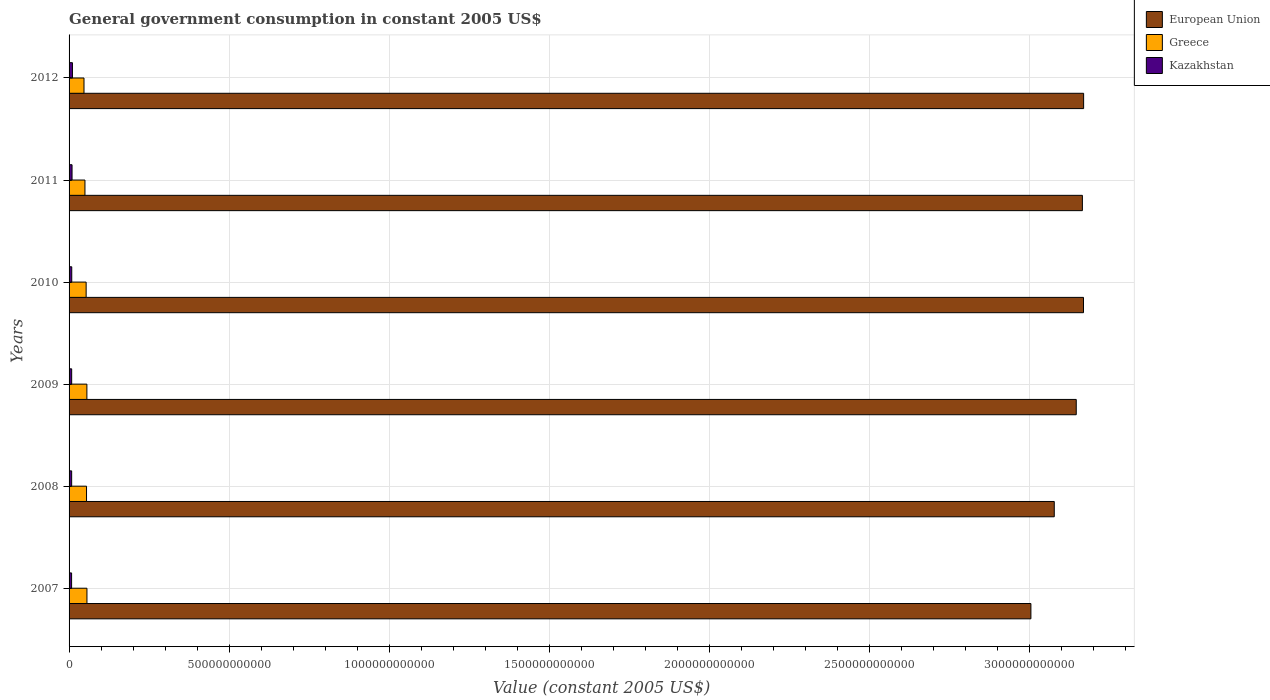How many bars are there on the 6th tick from the top?
Give a very brief answer. 3. What is the label of the 1st group of bars from the top?
Offer a terse response. 2012. What is the government conusmption in Kazakhstan in 2010?
Provide a succinct answer. 8.36e+09. Across all years, what is the maximum government conusmption in Greece?
Offer a very short reply. 5.58e+1. Across all years, what is the minimum government conusmption in European Union?
Your answer should be compact. 3.00e+12. In which year was the government conusmption in Kazakhstan maximum?
Your answer should be compact. 2012. What is the total government conusmption in Kazakhstan in the graph?
Your answer should be very brief. 5.23e+1. What is the difference between the government conusmption in European Union in 2009 and that in 2011?
Provide a short and direct response. -1.92e+1. What is the difference between the government conusmption in Greece in 2007 and the government conusmption in European Union in 2012?
Provide a succinct answer. -3.11e+12. What is the average government conusmption in Kazakhstan per year?
Make the answer very short. 8.71e+09. In the year 2009, what is the difference between the government conusmption in European Union and government conusmption in Kazakhstan?
Provide a succinct answer. 3.14e+12. What is the ratio of the government conusmption in Kazakhstan in 2007 to that in 2012?
Ensure brevity in your answer.  0.75. Is the government conusmption in Greece in 2007 less than that in 2009?
Ensure brevity in your answer.  No. What is the difference between the highest and the second highest government conusmption in Greece?
Keep it short and to the point. 1.99e+08. What is the difference between the highest and the lowest government conusmption in Greece?
Your answer should be compact. 9.24e+09. In how many years, is the government conusmption in Kazakhstan greater than the average government conusmption in Kazakhstan taken over all years?
Keep it short and to the point. 2. Is it the case that in every year, the sum of the government conusmption in European Union and government conusmption in Kazakhstan is greater than the government conusmption in Greece?
Your response must be concise. Yes. How many years are there in the graph?
Provide a succinct answer. 6. What is the difference between two consecutive major ticks on the X-axis?
Provide a short and direct response. 5.00e+11. Are the values on the major ticks of X-axis written in scientific E-notation?
Your response must be concise. No. Does the graph contain any zero values?
Your answer should be very brief. No. Does the graph contain grids?
Provide a succinct answer. Yes. Where does the legend appear in the graph?
Provide a succinct answer. Top right. What is the title of the graph?
Your response must be concise. General government consumption in constant 2005 US$. Does "Guam" appear as one of the legend labels in the graph?
Make the answer very short. No. What is the label or title of the X-axis?
Keep it short and to the point. Value (constant 2005 US$). What is the label or title of the Y-axis?
Your answer should be very brief. Years. What is the Value (constant 2005 US$) in European Union in 2007?
Provide a succinct answer. 3.00e+12. What is the Value (constant 2005 US$) in Greece in 2007?
Give a very brief answer. 5.58e+1. What is the Value (constant 2005 US$) of Kazakhstan in 2007?
Offer a very short reply. 7.86e+09. What is the Value (constant 2005 US$) of European Union in 2008?
Offer a very short reply. 3.08e+12. What is the Value (constant 2005 US$) of Greece in 2008?
Make the answer very short. 5.45e+1. What is the Value (constant 2005 US$) of Kazakhstan in 2008?
Give a very brief answer. 8.06e+09. What is the Value (constant 2005 US$) of European Union in 2009?
Provide a succinct answer. 3.15e+12. What is the Value (constant 2005 US$) in Greece in 2009?
Your answer should be compact. 5.56e+1. What is the Value (constant 2005 US$) of Kazakhstan in 2009?
Your answer should be compact. 8.14e+09. What is the Value (constant 2005 US$) in European Union in 2010?
Give a very brief answer. 3.17e+12. What is the Value (constant 2005 US$) of Greece in 2010?
Your response must be concise. 5.33e+1. What is the Value (constant 2005 US$) of Kazakhstan in 2010?
Your answer should be very brief. 8.36e+09. What is the Value (constant 2005 US$) of European Union in 2011?
Offer a terse response. 3.16e+12. What is the Value (constant 2005 US$) of Greece in 2011?
Keep it short and to the point. 4.96e+1. What is the Value (constant 2005 US$) of Kazakhstan in 2011?
Give a very brief answer. 9.31e+09. What is the Value (constant 2005 US$) in European Union in 2012?
Give a very brief answer. 3.17e+12. What is the Value (constant 2005 US$) in Greece in 2012?
Ensure brevity in your answer.  4.66e+1. What is the Value (constant 2005 US$) of Kazakhstan in 2012?
Offer a very short reply. 1.05e+1. Across all years, what is the maximum Value (constant 2005 US$) of European Union?
Give a very brief answer. 3.17e+12. Across all years, what is the maximum Value (constant 2005 US$) of Greece?
Keep it short and to the point. 5.58e+1. Across all years, what is the maximum Value (constant 2005 US$) in Kazakhstan?
Provide a succinct answer. 1.05e+1. Across all years, what is the minimum Value (constant 2005 US$) of European Union?
Offer a very short reply. 3.00e+12. Across all years, what is the minimum Value (constant 2005 US$) of Greece?
Offer a terse response. 4.66e+1. Across all years, what is the minimum Value (constant 2005 US$) of Kazakhstan?
Provide a short and direct response. 7.86e+09. What is the total Value (constant 2005 US$) in European Union in the graph?
Give a very brief answer. 1.87e+13. What is the total Value (constant 2005 US$) of Greece in the graph?
Keep it short and to the point. 3.16e+11. What is the total Value (constant 2005 US$) of Kazakhstan in the graph?
Your answer should be compact. 5.23e+1. What is the difference between the Value (constant 2005 US$) in European Union in 2007 and that in 2008?
Provide a succinct answer. -7.30e+1. What is the difference between the Value (constant 2005 US$) of Greece in 2007 and that in 2008?
Keep it short and to the point. 1.30e+09. What is the difference between the Value (constant 2005 US$) in Kazakhstan in 2007 and that in 2008?
Make the answer very short. -2.04e+08. What is the difference between the Value (constant 2005 US$) in European Union in 2007 and that in 2009?
Ensure brevity in your answer.  -1.42e+11. What is the difference between the Value (constant 2005 US$) of Greece in 2007 and that in 2009?
Your answer should be very brief. 1.99e+08. What is the difference between the Value (constant 2005 US$) in Kazakhstan in 2007 and that in 2009?
Ensure brevity in your answer.  -2.85e+08. What is the difference between the Value (constant 2005 US$) of European Union in 2007 and that in 2010?
Offer a terse response. -1.64e+11. What is the difference between the Value (constant 2005 US$) of Greece in 2007 and that in 2010?
Your response must be concise. 2.52e+09. What is the difference between the Value (constant 2005 US$) in Kazakhstan in 2007 and that in 2010?
Your answer should be very brief. -5.05e+08. What is the difference between the Value (constant 2005 US$) in European Union in 2007 and that in 2011?
Keep it short and to the point. -1.61e+11. What is the difference between the Value (constant 2005 US$) of Greece in 2007 and that in 2011?
Keep it short and to the point. 6.26e+09. What is the difference between the Value (constant 2005 US$) in Kazakhstan in 2007 and that in 2011?
Your answer should be compact. -1.45e+09. What is the difference between the Value (constant 2005 US$) of European Union in 2007 and that in 2012?
Offer a terse response. -1.65e+11. What is the difference between the Value (constant 2005 US$) of Greece in 2007 and that in 2012?
Keep it short and to the point. 9.24e+09. What is the difference between the Value (constant 2005 US$) in Kazakhstan in 2007 and that in 2012?
Your response must be concise. -2.68e+09. What is the difference between the Value (constant 2005 US$) in European Union in 2008 and that in 2009?
Your answer should be very brief. -6.86e+1. What is the difference between the Value (constant 2005 US$) in Greece in 2008 and that in 2009?
Offer a terse response. -1.10e+09. What is the difference between the Value (constant 2005 US$) of Kazakhstan in 2008 and that in 2009?
Offer a very short reply. -8.06e+07. What is the difference between the Value (constant 2005 US$) of European Union in 2008 and that in 2010?
Your response must be concise. -9.13e+1. What is the difference between the Value (constant 2005 US$) in Greece in 2008 and that in 2010?
Ensure brevity in your answer.  1.22e+09. What is the difference between the Value (constant 2005 US$) of Kazakhstan in 2008 and that in 2010?
Ensure brevity in your answer.  -3.01e+08. What is the difference between the Value (constant 2005 US$) in European Union in 2008 and that in 2011?
Ensure brevity in your answer.  -8.78e+1. What is the difference between the Value (constant 2005 US$) in Greece in 2008 and that in 2011?
Provide a succinct answer. 4.96e+09. What is the difference between the Value (constant 2005 US$) of Kazakhstan in 2008 and that in 2011?
Provide a short and direct response. -1.25e+09. What is the difference between the Value (constant 2005 US$) in European Union in 2008 and that in 2012?
Provide a short and direct response. -9.17e+1. What is the difference between the Value (constant 2005 US$) of Greece in 2008 and that in 2012?
Your response must be concise. 7.93e+09. What is the difference between the Value (constant 2005 US$) of Kazakhstan in 2008 and that in 2012?
Your answer should be very brief. -2.47e+09. What is the difference between the Value (constant 2005 US$) of European Union in 2009 and that in 2010?
Make the answer very short. -2.27e+1. What is the difference between the Value (constant 2005 US$) of Greece in 2009 and that in 2010?
Your answer should be very brief. 2.32e+09. What is the difference between the Value (constant 2005 US$) of Kazakhstan in 2009 and that in 2010?
Your answer should be very brief. -2.20e+08. What is the difference between the Value (constant 2005 US$) of European Union in 2009 and that in 2011?
Give a very brief answer. -1.92e+1. What is the difference between the Value (constant 2005 US$) of Greece in 2009 and that in 2011?
Offer a very short reply. 6.06e+09. What is the difference between the Value (constant 2005 US$) in Kazakhstan in 2009 and that in 2011?
Offer a very short reply. -1.17e+09. What is the difference between the Value (constant 2005 US$) of European Union in 2009 and that in 2012?
Your answer should be very brief. -2.31e+1. What is the difference between the Value (constant 2005 US$) of Greece in 2009 and that in 2012?
Your answer should be very brief. 9.04e+09. What is the difference between the Value (constant 2005 US$) in Kazakhstan in 2009 and that in 2012?
Your answer should be compact. -2.39e+09. What is the difference between the Value (constant 2005 US$) of European Union in 2010 and that in 2011?
Make the answer very short. 3.47e+09. What is the difference between the Value (constant 2005 US$) of Greece in 2010 and that in 2011?
Make the answer very short. 3.74e+09. What is the difference between the Value (constant 2005 US$) of Kazakhstan in 2010 and that in 2011?
Your answer should be compact. -9.45e+08. What is the difference between the Value (constant 2005 US$) in European Union in 2010 and that in 2012?
Your answer should be compact. -3.98e+08. What is the difference between the Value (constant 2005 US$) in Greece in 2010 and that in 2012?
Your answer should be compact. 6.72e+09. What is the difference between the Value (constant 2005 US$) in Kazakhstan in 2010 and that in 2012?
Your response must be concise. -2.17e+09. What is the difference between the Value (constant 2005 US$) in European Union in 2011 and that in 2012?
Offer a terse response. -3.87e+09. What is the difference between the Value (constant 2005 US$) of Greece in 2011 and that in 2012?
Provide a short and direct response. 2.97e+09. What is the difference between the Value (constant 2005 US$) of Kazakhstan in 2011 and that in 2012?
Provide a succinct answer. -1.23e+09. What is the difference between the Value (constant 2005 US$) of European Union in 2007 and the Value (constant 2005 US$) of Greece in 2008?
Keep it short and to the point. 2.95e+12. What is the difference between the Value (constant 2005 US$) in European Union in 2007 and the Value (constant 2005 US$) in Kazakhstan in 2008?
Give a very brief answer. 3.00e+12. What is the difference between the Value (constant 2005 US$) of Greece in 2007 and the Value (constant 2005 US$) of Kazakhstan in 2008?
Provide a short and direct response. 4.78e+1. What is the difference between the Value (constant 2005 US$) of European Union in 2007 and the Value (constant 2005 US$) of Greece in 2009?
Your answer should be very brief. 2.95e+12. What is the difference between the Value (constant 2005 US$) in European Union in 2007 and the Value (constant 2005 US$) in Kazakhstan in 2009?
Your answer should be very brief. 3.00e+12. What is the difference between the Value (constant 2005 US$) in Greece in 2007 and the Value (constant 2005 US$) in Kazakhstan in 2009?
Your response must be concise. 4.77e+1. What is the difference between the Value (constant 2005 US$) of European Union in 2007 and the Value (constant 2005 US$) of Greece in 2010?
Provide a short and direct response. 2.95e+12. What is the difference between the Value (constant 2005 US$) of European Union in 2007 and the Value (constant 2005 US$) of Kazakhstan in 2010?
Provide a succinct answer. 3.00e+12. What is the difference between the Value (constant 2005 US$) in Greece in 2007 and the Value (constant 2005 US$) in Kazakhstan in 2010?
Give a very brief answer. 4.75e+1. What is the difference between the Value (constant 2005 US$) of European Union in 2007 and the Value (constant 2005 US$) of Greece in 2011?
Provide a succinct answer. 2.95e+12. What is the difference between the Value (constant 2005 US$) in European Union in 2007 and the Value (constant 2005 US$) in Kazakhstan in 2011?
Your response must be concise. 2.99e+12. What is the difference between the Value (constant 2005 US$) of Greece in 2007 and the Value (constant 2005 US$) of Kazakhstan in 2011?
Ensure brevity in your answer.  4.65e+1. What is the difference between the Value (constant 2005 US$) in European Union in 2007 and the Value (constant 2005 US$) in Greece in 2012?
Ensure brevity in your answer.  2.96e+12. What is the difference between the Value (constant 2005 US$) of European Union in 2007 and the Value (constant 2005 US$) of Kazakhstan in 2012?
Offer a very short reply. 2.99e+12. What is the difference between the Value (constant 2005 US$) in Greece in 2007 and the Value (constant 2005 US$) in Kazakhstan in 2012?
Your response must be concise. 4.53e+1. What is the difference between the Value (constant 2005 US$) of European Union in 2008 and the Value (constant 2005 US$) of Greece in 2009?
Make the answer very short. 3.02e+12. What is the difference between the Value (constant 2005 US$) of European Union in 2008 and the Value (constant 2005 US$) of Kazakhstan in 2009?
Give a very brief answer. 3.07e+12. What is the difference between the Value (constant 2005 US$) in Greece in 2008 and the Value (constant 2005 US$) in Kazakhstan in 2009?
Give a very brief answer. 4.64e+1. What is the difference between the Value (constant 2005 US$) in European Union in 2008 and the Value (constant 2005 US$) in Greece in 2010?
Your answer should be compact. 3.02e+12. What is the difference between the Value (constant 2005 US$) of European Union in 2008 and the Value (constant 2005 US$) of Kazakhstan in 2010?
Provide a short and direct response. 3.07e+12. What is the difference between the Value (constant 2005 US$) of Greece in 2008 and the Value (constant 2005 US$) of Kazakhstan in 2010?
Your answer should be compact. 4.62e+1. What is the difference between the Value (constant 2005 US$) in European Union in 2008 and the Value (constant 2005 US$) in Greece in 2011?
Your answer should be very brief. 3.03e+12. What is the difference between the Value (constant 2005 US$) of European Union in 2008 and the Value (constant 2005 US$) of Kazakhstan in 2011?
Provide a succinct answer. 3.07e+12. What is the difference between the Value (constant 2005 US$) of Greece in 2008 and the Value (constant 2005 US$) of Kazakhstan in 2011?
Your response must be concise. 4.52e+1. What is the difference between the Value (constant 2005 US$) of European Union in 2008 and the Value (constant 2005 US$) of Greece in 2012?
Your answer should be very brief. 3.03e+12. What is the difference between the Value (constant 2005 US$) in European Union in 2008 and the Value (constant 2005 US$) in Kazakhstan in 2012?
Make the answer very short. 3.07e+12. What is the difference between the Value (constant 2005 US$) of Greece in 2008 and the Value (constant 2005 US$) of Kazakhstan in 2012?
Offer a very short reply. 4.40e+1. What is the difference between the Value (constant 2005 US$) in European Union in 2009 and the Value (constant 2005 US$) in Greece in 2010?
Provide a succinct answer. 3.09e+12. What is the difference between the Value (constant 2005 US$) of European Union in 2009 and the Value (constant 2005 US$) of Kazakhstan in 2010?
Ensure brevity in your answer.  3.14e+12. What is the difference between the Value (constant 2005 US$) of Greece in 2009 and the Value (constant 2005 US$) of Kazakhstan in 2010?
Your answer should be very brief. 4.73e+1. What is the difference between the Value (constant 2005 US$) of European Union in 2009 and the Value (constant 2005 US$) of Greece in 2011?
Ensure brevity in your answer.  3.10e+12. What is the difference between the Value (constant 2005 US$) in European Union in 2009 and the Value (constant 2005 US$) in Kazakhstan in 2011?
Your response must be concise. 3.14e+12. What is the difference between the Value (constant 2005 US$) in Greece in 2009 and the Value (constant 2005 US$) in Kazakhstan in 2011?
Provide a succinct answer. 4.63e+1. What is the difference between the Value (constant 2005 US$) of European Union in 2009 and the Value (constant 2005 US$) of Greece in 2012?
Your answer should be very brief. 3.10e+12. What is the difference between the Value (constant 2005 US$) in European Union in 2009 and the Value (constant 2005 US$) in Kazakhstan in 2012?
Ensure brevity in your answer.  3.13e+12. What is the difference between the Value (constant 2005 US$) in Greece in 2009 and the Value (constant 2005 US$) in Kazakhstan in 2012?
Provide a succinct answer. 4.51e+1. What is the difference between the Value (constant 2005 US$) of European Union in 2010 and the Value (constant 2005 US$) of Greece in 2011?
Ensure brevity in your answer.  3.12e+12. What is the difference between the Value (constant 2005 US$) in European Union in 2010 and the Value (constant 2005 US$) in Kazakhstan in 2011?
Give a very brief answer. 3.16e+12. What is the difference between the Value (constant 2005 US$) in Greece in 2010 and the Value (constant 2005 US$) in Kazakhstan in 2011?
Keep it short and to the point. 4.40e+1. What is the difference between the Value (constant 2005 US$) of European Union in 2010 and the Value (constant 2005 US$) of Greece in 2012?
Offer a terse response. 3.12e+12. What is the difference between the Value (constant 2005 US$) in European Union in 2010 and the Value (constant 2005 US$) in Kazakhstan in 2012?
Offer a very short reply. 3.16e+12. What is the difference between the Value (constant 2005 US$) of Greece in 2010 and the Value (constant 2005 US$) of Kazakhstan in 2012?
Your answer should be very brief. 4.28e+1. What is the difference between the Value (constant 2005 US$) of European Union in 2011 and the Value (constant 2005 US$) of Greece in 2012?
Provide a succinct answer. 3.12e+12. What is the difference between the Value (constant 2005 US$) of European Union in 2011 and the Value (constant 2005 US$) of Kazakhstan in 2012?
Provide a succinct answer. 3.15e+12. What is the difference between the Value (constant 2005 US$) of Greece in 2011 and the Value (constant 2005 US$) of Kazakhstan in 2012?
Your answer should be compact. 3.90e+1. What is the average Value (constant 2005 US$) of European Union per year?
Keep it short and to the point. 3.12e+12. What is the average Value (constant 2005 US$) in Greece per year?
Offer a terse response. 5.26e+1. What is the average Value (constant 2005 US$) of Kazakhstan per year?
Ensure brevity in your answer.  8.71e+09. In the year 2007, what is the difference between the Value (constant 2005 US$) of European Union and Value (constant 2005 US$) of Greece?
Give a very brief answer. 2.95e+12. In the year 2007, what is the difference between the Value (constant 2005 US$) in European Union and Value (constant 2005 US$) in Kazakhstan?
Provide a short and direct response. 3.00e+12. In the year 2007, what is the difference between the Value (constant 2005 US$) in Greece and Value (constant 2005 US$) in Kazakhstan?
Your answer should be compact. 4.80e+1. In the year 2008, what is the difference between the Value (constant 2005 US$) in European Union and Value (constant 2005 US$) in Greece?
Offer a very short reply. 3.02e+12. In the year 2008, what is the difference between the Value (constant 2005 US$) of European Union and Value (constant 2005 US$) of Kazakhstan?
Provide a succinct answer. 3.07e+12. In the year 2008, what is the difference between the Value (constant 2005 US$) in Greece and Value (constant 2005 US$) in Kazakhstan?
Keep it short and to the point. 4.65e+1. In the year 2009, what is the difference between the Value (constant 2005 US$) of European Union and Value (constant 2005 US$) of Greece?
Provide a succinct answer. 3.09e+12. In the year 2009, what is the difference between the Value (constant 2005 US$) in European Union and Value (constant 2005 US$) in Kazakhstan?
Ensure brevity in your answer.  3.14e+12. In the year 2009, what is the difference between the Value (constant 2005 US$) in Greece and Value (constant 2005 US$) in Kazakhstan?
Your answer should be compact. 4.75e+1. In the year 2010, what is the difference between the Value (constant 2005 US$) of European Union and Value (constant 2005 US$) of Greece?
Give a very brief answer. 3.11e+12. In the year 2010, what is the difference between the Value (constant 2005 US$) in European Union and Value (constant 2005 US$) in Kazakhstan?
Provide a short and direct response. 3.16e+12. In the year 2010, what is the difference between the Value (constant 2005 US$) of Greece and Value (constant 2005 US$) of Kazakhstan?
Make the answer very short. 4.50e+1. In the year 2011, what is the difference between the Value (constant 2005 US$) in European Union and Value (constant 2005 US$) in Greece?
Ensure brevity in your answer.  3.11e+12. In the year 2011, what is the difference between the Value (constant 2005 US$) of European Union and Value (constant 2005 US$) of Kazakhstan?
Your answer should be very brief. 3.16e+12. In the year 2011, what is the difference between the Value (constant 2005 US$) of Greece and Value (constant 2005 US$) of Kazakhstan?
Provide a succinct answer. 4.03e+1. In the year 2012, what is the difference between the Value (constant 2005 US$) of European Union and Value (constant 2005 US$) of Greece?
Your response must be concise. 3.12e+12. In the year 2012, what is the difference between the Value (constant 2005 US$) in European Union and Value (constant 2005 US$) in Kazakhstan?
Ensure brevity in your answer.  3.16e+12. In the year 2012, what is the difference between the Value (constant 2005 US$) of Greece and Value (constant 2005 US$) of Kazakhstan?
Your response must be concise. 3.61e+1. What is the ratio of the Value (constant 2005 US$) in European Union in 2007 to that in 2008?
Your answer should be compact. 0.98. What is the ratio of the Value (constant 2005 US$) in Greece in 2007 to that in 2008?
Provide a succinct answer. 1.02. What is the ratio of the Value (constant 2005 US$) in Kazakhstan in 2007 to that in 2008?
Give a very brief answer. 0.97. What is the ratio of the Value (constant 2005 US$) in European Union in 2007 to that in 2009?
Your answer should be compact. 0.95. What is the ratio of the Value (constant 2005 US$) in Greece in 2007 to that in 2009?
Offer a terse response. 1. What is the ratio of the Value (constant 2005 US$) in Kazakhstan in 2007 to that in 2009?
Offer a terse response. 0.96. What is the ratio of the Value (constant 2005 US$) of European Union in 2007 to that in 2010?
Provide a succinct answer. 0.95. What is the ratio of the Value (constant 2005 US$) in Greece in 2007 to that in 2010?
Provide a short and direct response. 1.05. What is the ratio of the Value (constant 2005 US$) in Kazakhstan in 2007 to that in 2010?
Provide a succinct answer. 0.94. What is the ratio of the Value (constant 2005 US$) in European Union in 2007 to that in 2011?
Provide a succinct answer. 0.95. What is the ratio of the Value (constant 2005 US$) of Greece in 2007 to that in 2011?
Provide a succinct answer. 1.13. What is the ratio of the Value (constant 2005 US$) in Kazakhstan in 2007 to that in 2011?
Your answer should be compact. 0.84. What is the ratio of the Value (constant 2005 US$) in European Union in 2007 to that in 2012?
Your answer should be very brief. 0.95. What is the ratio of the Value (constant 2005 US$) in Greece in 2007 to that in 2012?
Make the answer very short. 1.2. What is the ratio of the Value (constant 2005 US$) of Kazakhstan in 2007 to that in 2012?
Provide a succinct answer. 0.75. What is the ratio of the Value (constant 2005 US$) of European Union in 2008 to that in 2009?
Your answer should be very brief. 0.98. What is the ratio of the Value (constant 2005 US$) in Greece in 2008 to that in 2009?
Give a very brief answer. 0.98. What is the ratio of the Value (constant 2005 US$) in Kazakhstan in 2008 to that in 2009?
Your answer should be very brief. 0.99. What is the ratio of the Value (constant 2005 US$) of European Union in 2008 to that in 2010?
Your answer should be very brief. 0.97. What is the ratio of the Value (constant 2005 US$) of Greece in 2008 to that in 2010?
Keep it short and to the point. 1.02. What is the ratio of the Value (constant 2005 US$) in Kazakhstan in 2008 to that in 2010?
Your response must be concise. 0.96. What is the ratio of the Value (constant 2005 US$) of European Union in 2008 to that in 2011?
Your response must be concise. 0.97. What is the ratio of the Value (constant 2005 US$) in Kazakhstan in 2008 to that in 2011?
Offer a terse response. 0.87. What is the ratio of the Value (constant 2005 US$) of European Union in 2008 to that in 2012?
Provide a short and direct response. 0.97. What is the ratio of the Value (constant 2005 US$) of Greece in 2008 to that in 2012?
Offer a terse response. 1.17. What is the ratio of the Value (constant 2005 US$) in Kazakhstan in 2008 to that in 2012?
Your answer should be very brief. 0.77. What is the ratio of the Value (constant 2005 US$) in Greece in 2009 to that in 2010?
Your answer should be compact. 1.04. What is the ratio of the Value (constant 2005 US$) of Kazakhstan in 2009 to that in 2010?
Your answer should be compact. 0.97. What is the ratio of the Value (constant 2005 US$) in Greece in 2009 to that in 2011?
Give a very brief answer. 1.12. What is the ratio of the Value (constant 2005 US$) in Kazakhstan in 2009 to that in 2011?
Offer a terse response. 0.87. What is the ratio of the Value (constant 2005 US$) of European Union in 2009 to that in 2012?
Give a very brief answer. 0.99. What is the ratio of the Value (constant 2005 US$) of Greece in 2009 to that in 2012?
Provide a succinct answer. 1.19. What is the ratio of the Value (constant 2005 US$) in Kazakhstan in 2009 to that in 2012?
Make the answer very short. 0.77. What is the ratio of the Value (constant 2005 US$) of Greece in 2010 to that in 2011?
Your answer should be very brief. 1.08. What is the ratio of the Value (constant 2005 US$) of Kazakhstan in 2010 to that in 2011?
Ensure brevity in your answer.  0.9. What is the ratio of the Value (constant 2005 US$) in European Union in 2010 to that in 2012?
Provide a succinct answer. 1. What is the ratio of the Value (constant 2005 US$) of Greece in 2010 to that in 2012?
Offer a very short reply. 1.14. What is the ratio of the Value (constant 2005 US$) in Kazakhstan in 2010 to that in 2012?
Your answer should be very brief. 0.79. What is the ratio of the Value (constant 2005 US$) of European Union in 2011 to that in 2012?
Your answer should be very brief. 1. What is the ratio of the Value (constant 2005 US$) of Greece in 2011 to that in 2012?
Offer a terse response. 1.06. What is the ratio of the Value (constant 2005 US$) of Kazakhstan in 2011 to that in 2012?
Provide a succinct answer. 0.88. What is the difference between the highest and the second highest Value (constant 2005 US$) in European Union?
Give a very brief answer. 3.98e+08. What is the difference between the highest and the second highest Value (constant 2005 US$) in Greece?
Provide a succinct answer. 1.99e+08. What is the difference between the highest and the second highest Value (constant 2005 US$) in Kazakhstan?
Make the answer very short. 1.23e+09. What is the difference between the highest and the lowest Value (constant 2005 US$) of European Union?
Your response must be concise. 1.65e+11. What is the difference between the highest and the lowest Value (constant 2005 US$) of Greece?
Ensure brevity in your answer.  9.24e+09. What is the difference between the highest and the lowest Value (constant 2005 US$) in Kazakhstan?
Your answer should be compact. 2.68e+09. 